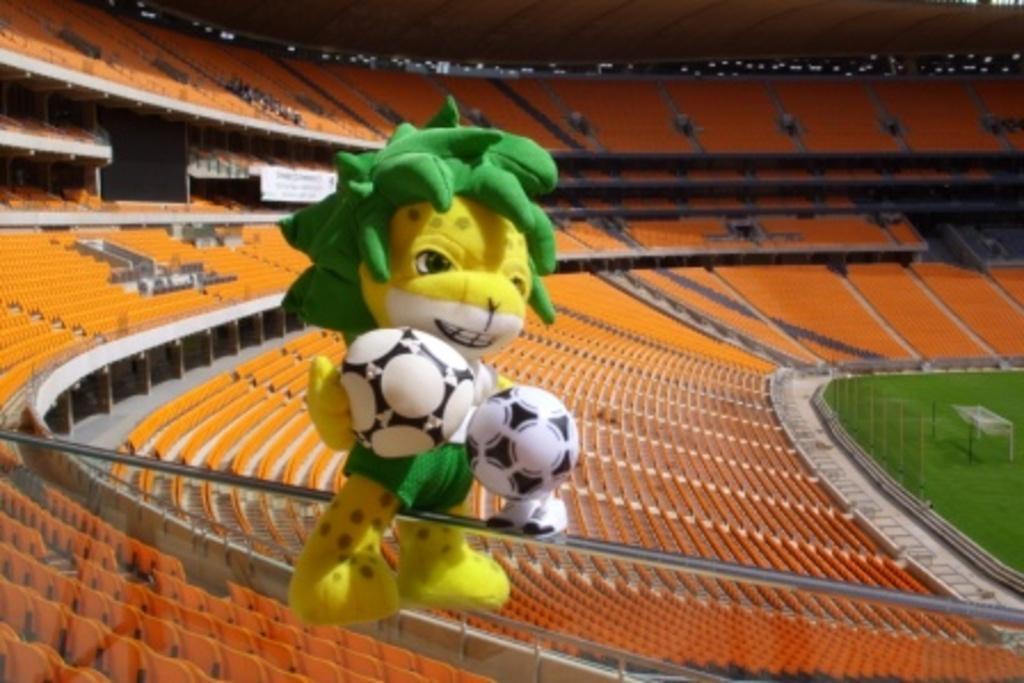What type of structure is shown in the image? There is a stadium in the image. What can be found inside the stadium? There are seats in the stadium. Is there any other object visible in the image? Yes, there is a toy on a metal rod in the image. What arithmetic problem is being solved on the brick in the image? There is no arithmetic problem or brick present in the image. What type of current is flowing through the toy on the metal rod? There is no information about any current flowing through the toy on the metal rod in the image. 